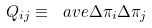<formula> <loc_0><loc_0><loc_500><loc_500>Q _ { i j } \equiv \ a v e { \Delta \pi _ { i } \Delta \pi _ { j } }</formula> 